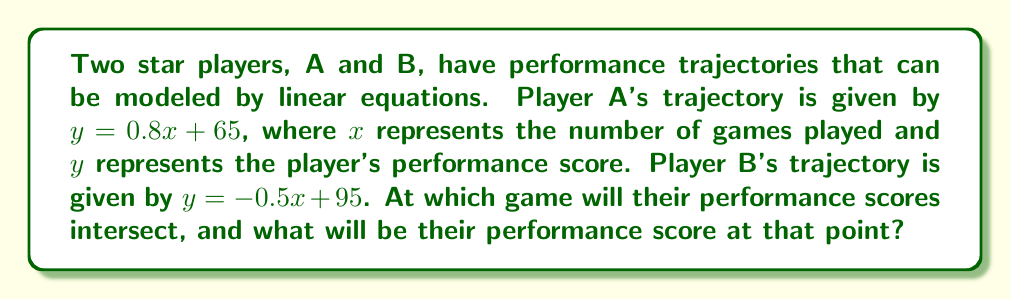Could you help me with this problem? To solve this problem, we need to find the intersection point of the two linear equations representing the players' performance trajectories. Let's approach this step-by-step:

1) We have two equations:
   Player A: $y = 0.8x + 65$
   Player B: $y = -0.5x + 95$

2) At the intersection point, both equations will yield the same $y$ value. So we can set them equal to each other:

   $0.8x + 65 = -0.5x + 95$

3) Now we solve this equation for $x$:

   $0.8x + 65 = -0.5x + 95$
   $0.8x + 0.5x = 95 - 65$
   $1.3x = 30$
   $x = \frac{30}{1.3} = 23.0769...$

4) Since we're dealing with number of games, we round this to the nearest whole number: 23 games.

5) To find the performance score at this intersection, we can plug $x = 23$ into either of the original equations. Let's use Player A's equation:

   $y = 0.8(23) + 65 = 18.4 + 65 = 83.4$

Therefore, the players' performance scores will intersect after 23 games, at a score of approximately 83.4.
Answer: The performance scores will intersect after 23 games, at a score of approximately 83.4. 